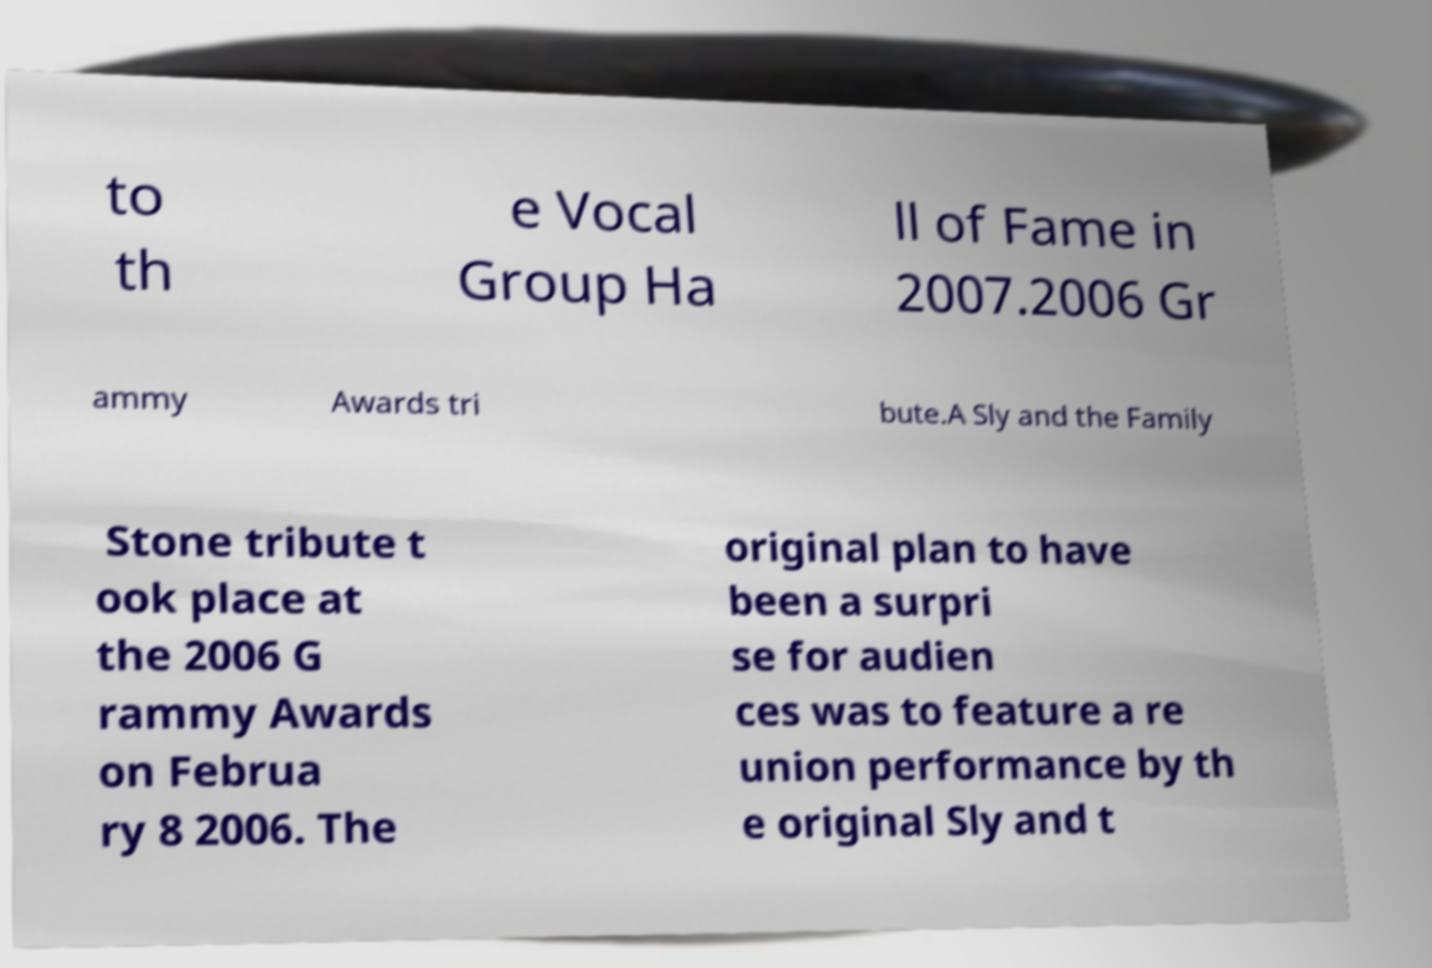Can you read and provide the text displayed in the image?This photo seems to have some interesting text. Can you extract and type it out for me? to th e Vocal Group Ha ll of Fame in 2007.2006 Gr ammy Awards tri bute.A Sly and the Family Stone tribute t ook place at the 2006 G rammy Awards on Februa ry 8 2006. The original plan to have been a surpri se for audien ces was to feature a re union performance by th e original Sly and t 